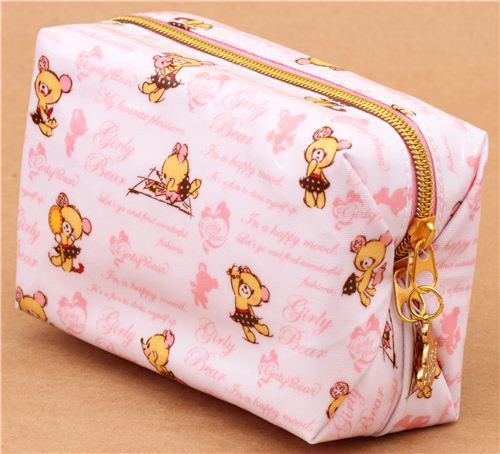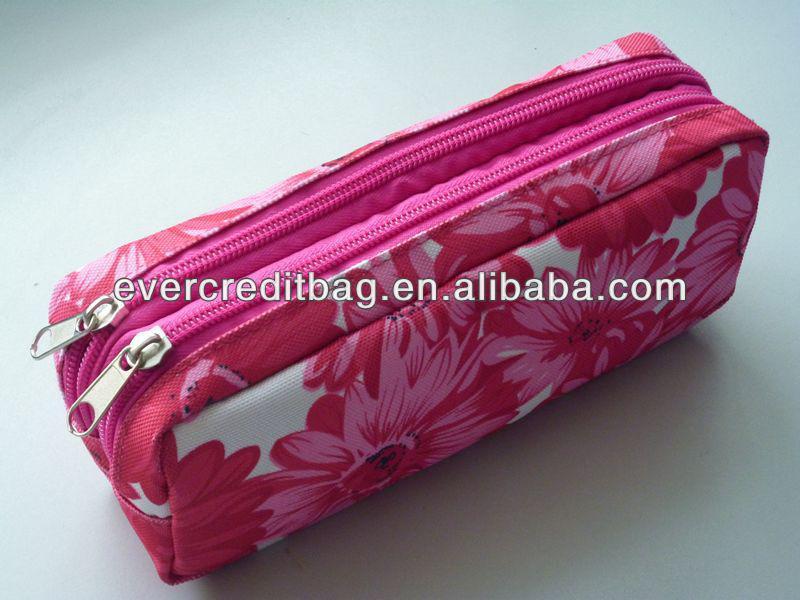The first image is the image on the left, the second image is the image on the right. Assess this claim about the two images: "The bag on the left is a rectangular cuboid.". Correct or not? Answer yes or no. Yes. The first image is the image on the left, the second image is the image on the right. Examine the images to the left and right. Is the description "The left image features a case with one zipper across the top, with a charm attached to the zipper pull, and an all-over print depicting cute animals, and the right image shows a mostly pink case closest to the camera." accurate? Answer yes or no. Yes. 